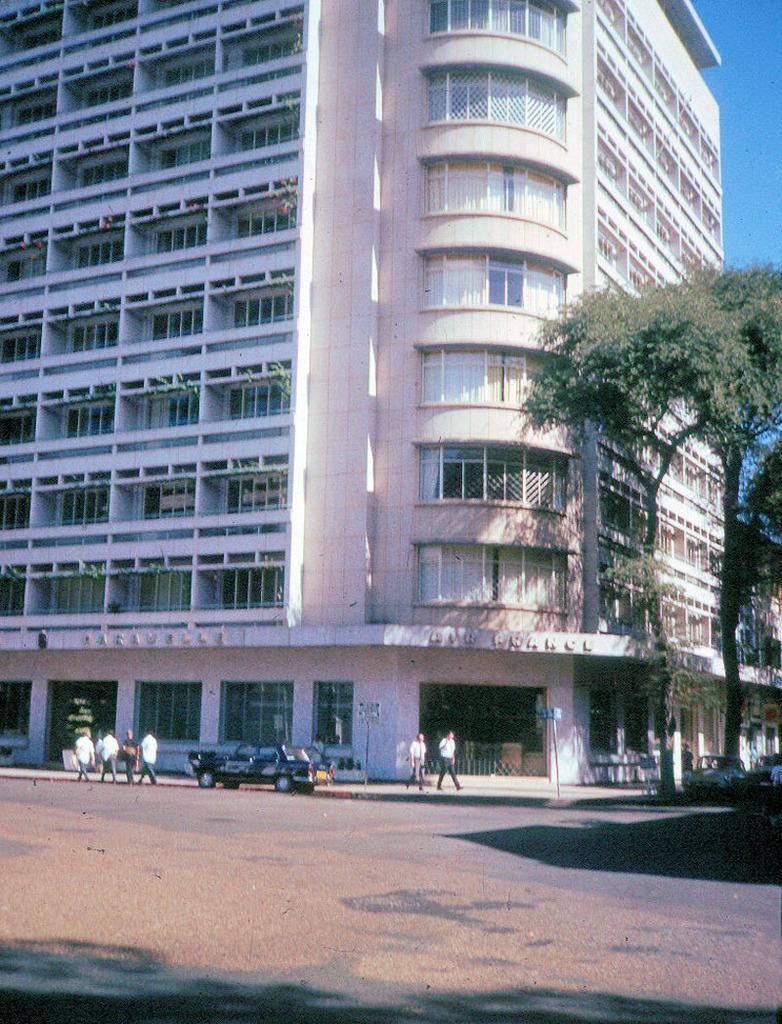How would you summarize this image in a sentence or two? In this image I can see a building, number of windows, few trees, the sky, shadows, a vehicle and here I can see few people are standing. 